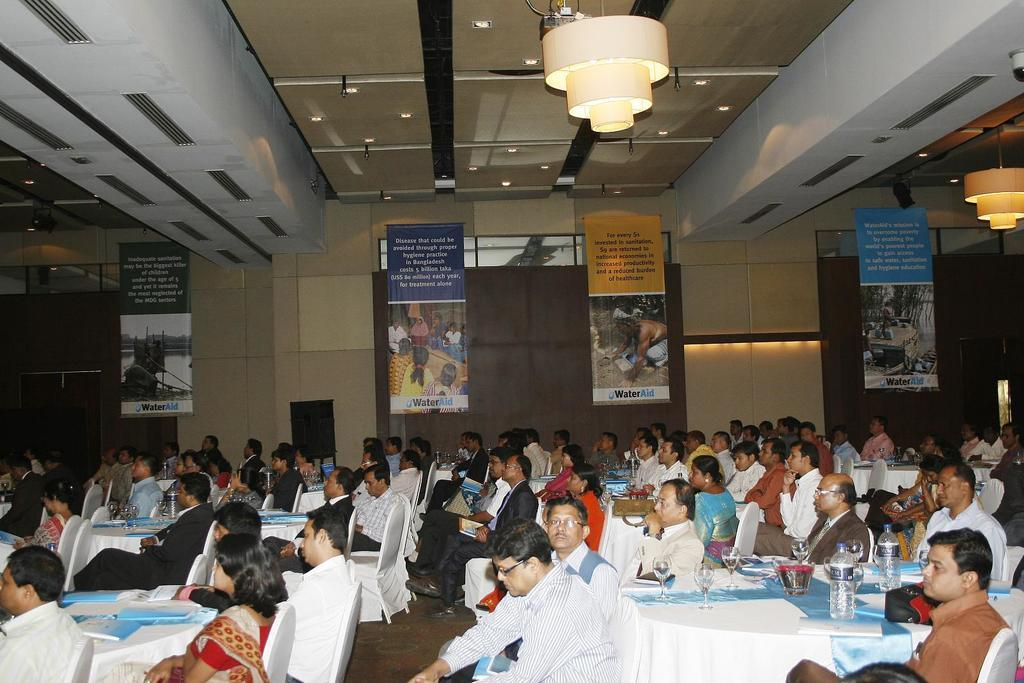What is attached to the rooftop in the image? Lights are attached to the rooftop. What decorative elements can be seen in the image? Banners are present in the image. What are the people in the image doing? People are sitting on chairs. What furniture is visible in the image? Tables are visible in the image. What items are on the tables? Glasses, bottles, and books are on the tables. Can you tell me how many tanks are visible in the image? There are no tanks present in the image. What type of ball is being used by the people sitting on chairs? There is no ball present in the image; people are sitting on chairs and there are tables with glasses, bottles, and books. 